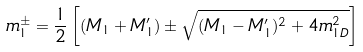Convert formula to latex. <formula><loc_0><loc_0><loc_500><loc_500>m _ { 1 } ^ { \pm } = \frac { 1 } { 2 } \left [ ( M _ { 1 } + M _ { 1 } ^ { \prime } ) \pm \sqrt { ( M _ { 1 } - M _ { 1 } ^ { \prime } ) ^ { 2 } + 4 m _ { 1 D } ^ { 2 } } \right ]</formula> 